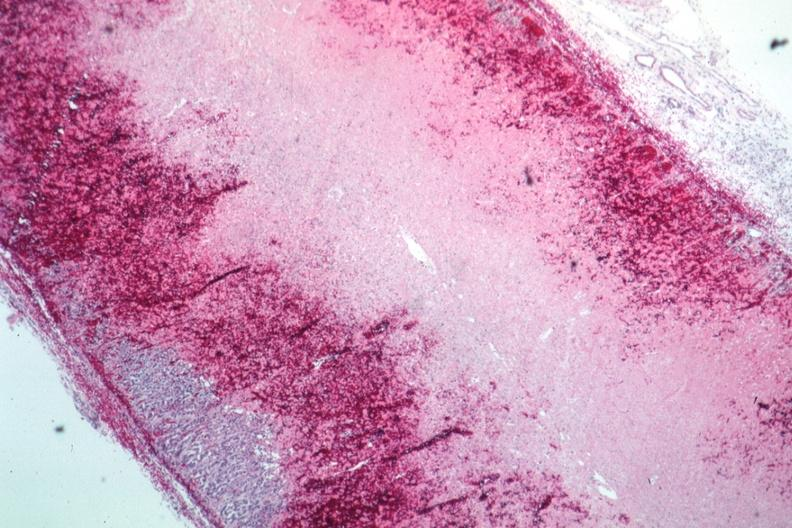s endocrine present?
Answer the question using a single word or phrase. Yes 